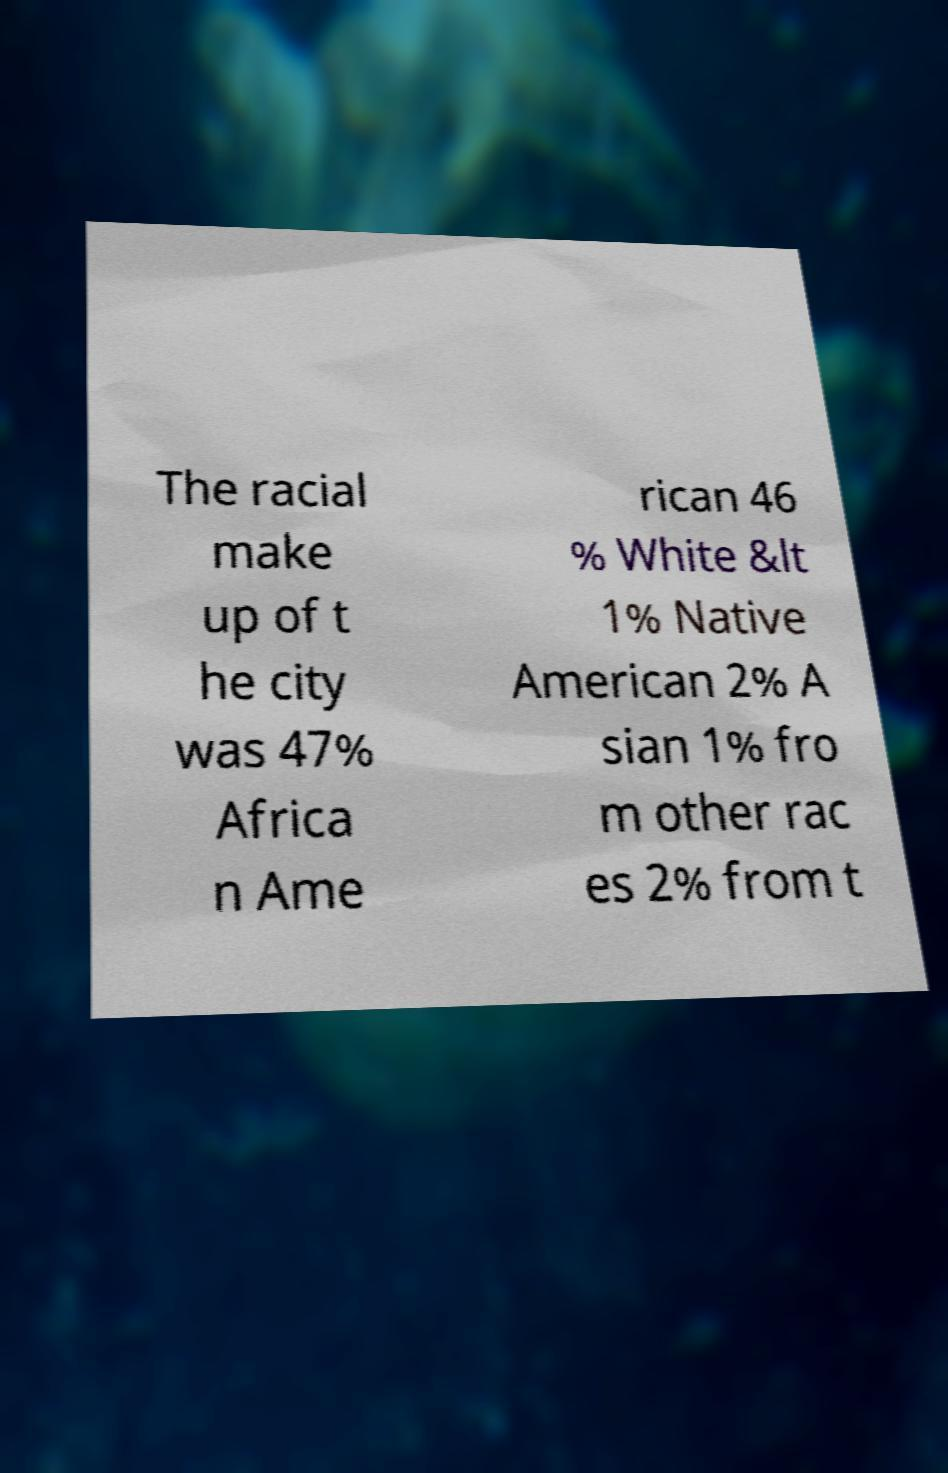Can you read and provide the text displayed in the image?This photo seems to have some interesting text. Can you extract and type it out for me? The racial make up of t he city was 47% Africa n Ame rican 46 % White &lt 1% Native American 2% A sian 1% fro m other rac es 2% from t 